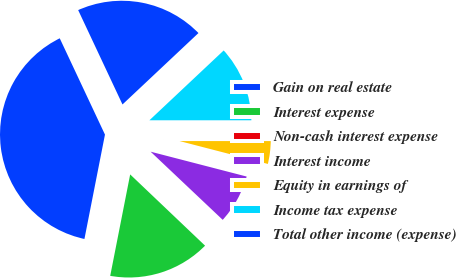Convert chart. <chart><loc_0><loc_0><loc_500><loc_500><pie_chart><fcel>Gain on real estate<fcel>Interest expense<fcel>Non-cash interest expense<fcel>Interest income<fcel>Equity in earnings of<fcel>Income tax expense<fcel>Total other income (expense)<nl><fcel>39.92%<fcel>15.99%<fcel>0.05%<fcel>8.02%<fcel>4.03%<fcel>12.01%<fcel>19.98%<nl></chart> 